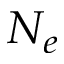<formula> <loc_0><loc_0><loc_500><loc_500>N _ { e }</formula> 